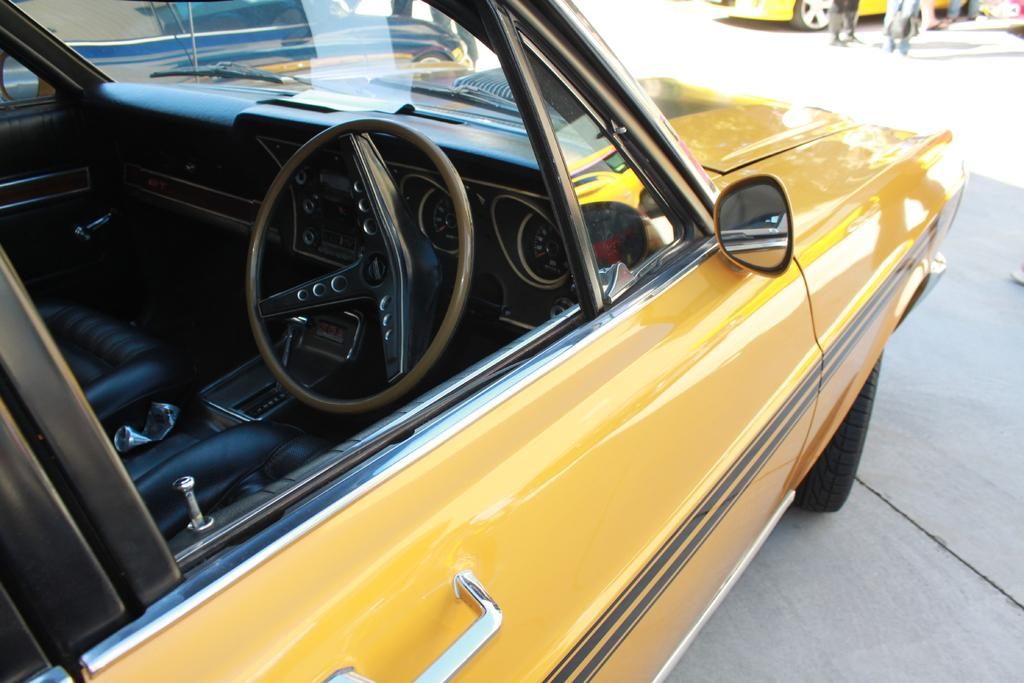What color is the car that is the main subject of the image? The car in the image is yellow. Where is the yellow car located in the image? The yellow car is in the front of the image. What can be seen in the background of the image? In the background of the image, there are legs of people and another car. What parts of the yellow car are visible? The front seats and the steering wheel of the yellow car are visible. Can you see a rat sitting on the boot of the yellow car in the image? There is no rat or boot visible in the image; it only features a yellow car with its front seats and steering wheel visible. 